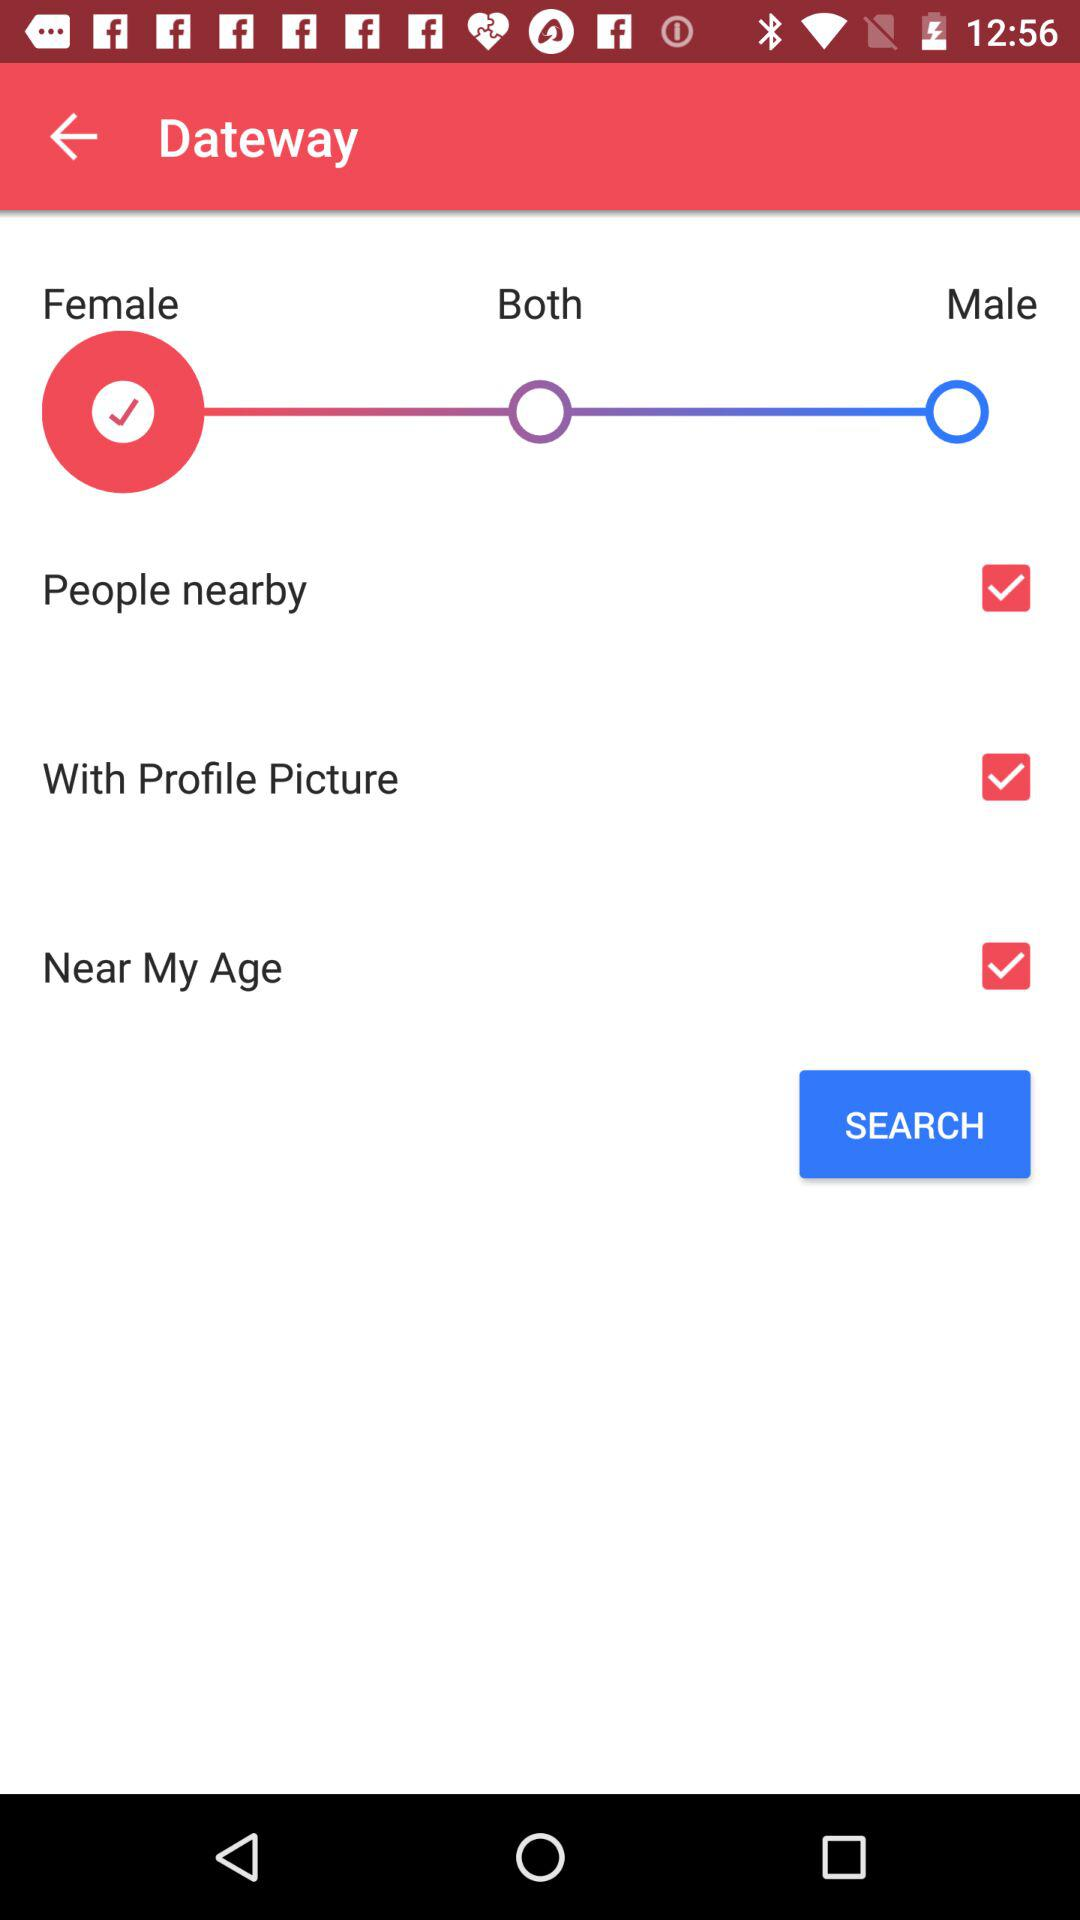How many options are there to define gender?
Answer the question using a single word or phrase. 3 